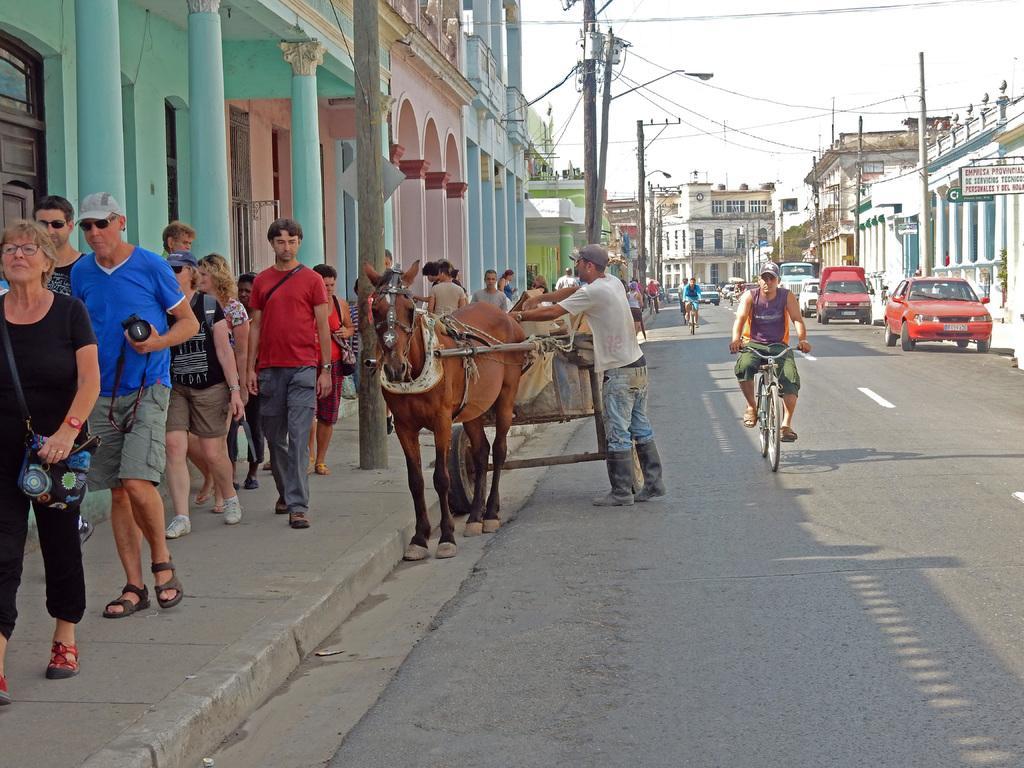Could you give a brief overview of what you see in this image? The image is taken on the streets of a city. On the left there are people walking on the footpath and there are buildings. In the center of the picture it is road, on the road there are vehicles, bicycles, horse cart, people current poles, street lights and cables. On the right there are buildings. In the center of the background there are buildings and sky. 